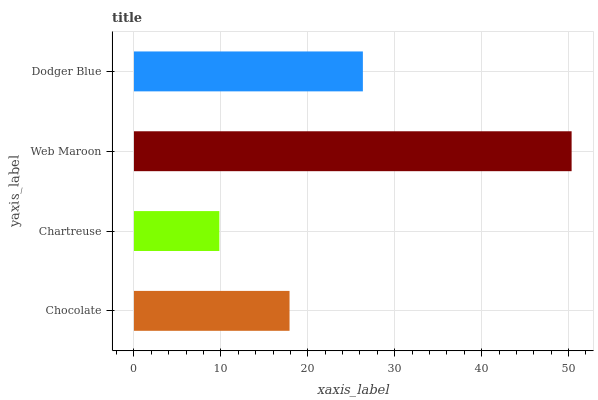Is Chartreuse the minimum?
Answer yes or no. Yes. Is Web Maroon the maximum?
Answer yes or no. Yes. Is Web Maroon the minimum?
Answer yes or no. No. Is Chartreuse the maximum?
Answer yes or no. No. Is Web Maroon greater than Chartreuse?
Answer yes or no. Yes. Is Chartreuse less than Web Maroon?
Answer yes or no. Yes. Is Chartreuse greater than Web Maroon?
Answer yes or no. No. Is Web Maroon less than Chartreuse?
Answer yes or no. No. Is Dodger Blue the high median?
Answer yes or no. Yes. Is Chocolate the low median?
Answer yes or no. Yes. Is Chartreuse the high median?
Answer yes or no. No. Is Dodger Blue the low median?
Answer yes or no. No. 